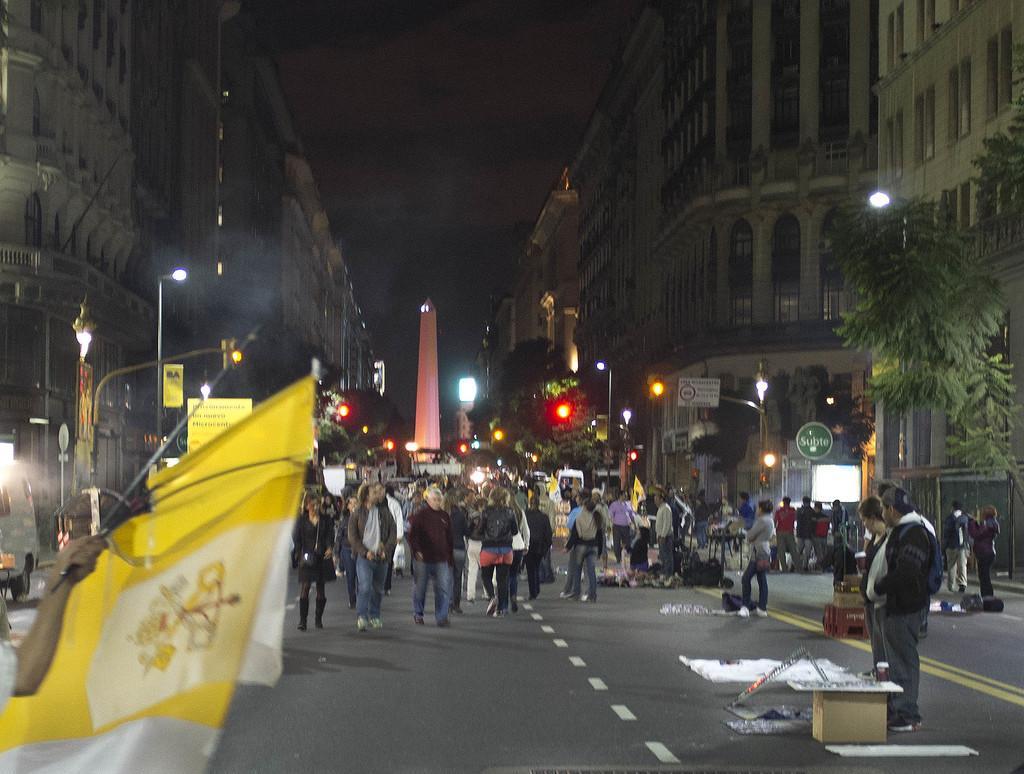How would you summarize this image in a sentence or two? In the image few people are standing and walking on the road and there are some boxes and products. In the bottom left side of the image a person is holding some flags. Behind the flags there is a vehicle and poles and sign boards. In the middle of the image there are some trees and buildings and lights. 